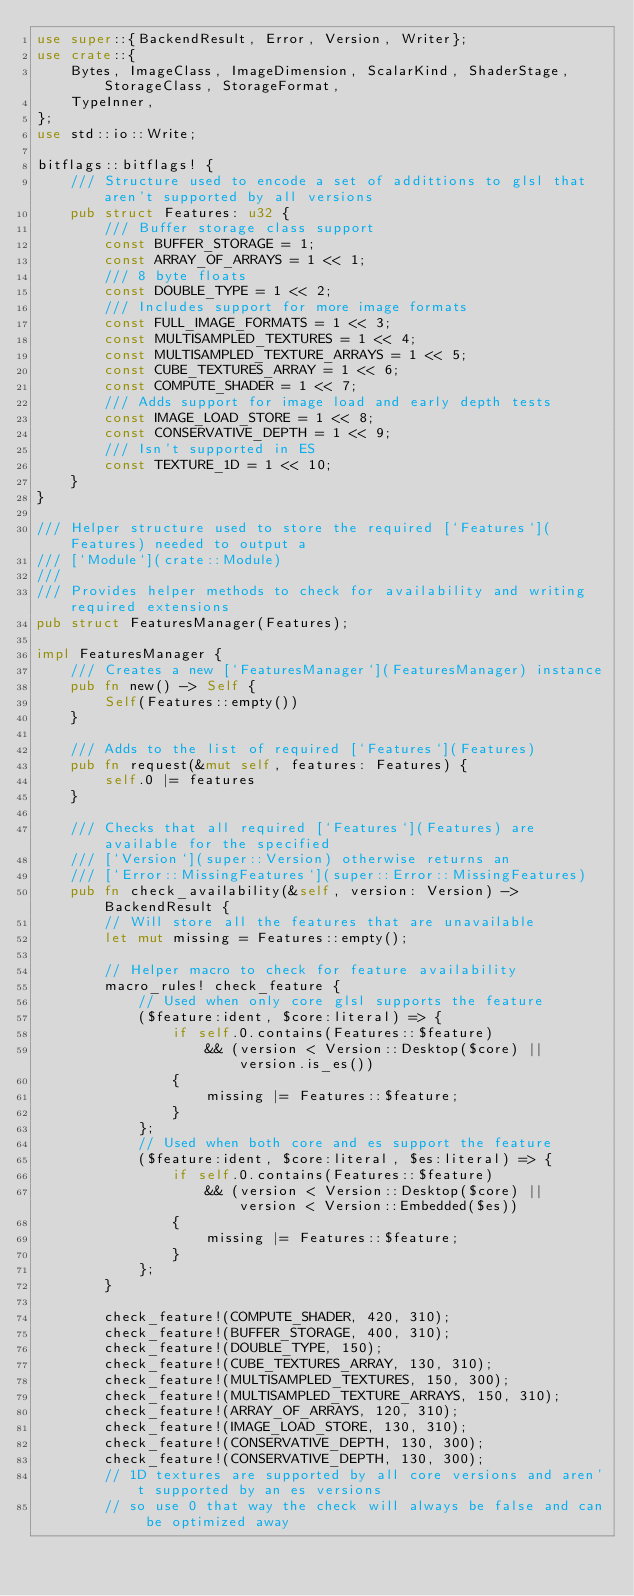<code> <loc_0><loc_0><loc_500><loc_500><_Rust_>use super::{BackendResult, Error, Version, Writer};
use crate::{
    Bytes, ImageClass, ImageDimension, ScalarKind, ShaderStage, StorageClass, StorageFormat,
    TypeInner,
};
use std::io::Write;

bitflags::bitflags! {
    /// Structure used to encode a set of addittions to glsl that aren't supported by all versions
    pub struct Features: u32 {
        /// Buffer storage class support
        const BUFFER_STORAGE = 1;
        const ARRAY_OF_ARRAYS = 1 << 1;
        /// 8 byte floats
        const DOUBLE_TYPE = 1 << 2;
        /// Includes support for more image formats
        const FULL_IMAGE_FORMATS = 1 << 3;
        const MULTISAMPLED_TEXTURES = 1 << 4;
        const MULTISAMPLED_TEXTURE_ARRAYS = 1 << 5;
        const CUBE_TEXTURES_ARRAY = 1 << 6;
        const COMPUTE_SHADER = 1 << 7;
        /// Adds support for image load and early depth tests
        const IMAGE_LOAD_STORE = 1 << 8;
        const CONSERVATIVE_DEPTH = 1 << 9;
        /// Isn't supported in ES
        const TEXTURE_1D = 1 << 10;
    }
}

/// Helper structure used to store the required [`Features`](Features) needed to output a
/// [`Module`](crate::Module)
///
/// Provides helper methods to check for availability and writing required extensions
pub struct FeaturesManager(Features);

impl FeaturesManager {
    /// Creates a new [`FeaturesManager`](FeaturesManager) instance
    pub fn new() -> Self {
        Self(Features::empty())
    }

    /// Adds to the list of required [`Features`](Features)
    pub fn request(&mut self, features: Features) {
        self.0 |= features
    }

    /// Checks that all required [`Features`](Features) are available for the specified
    /// [`Version`](super::Version) otherwise returns an
    /// [`Error::MissingFeatures`](super::Error::MissingFeatures)
    pub fn check_availability(&self, version: Version) -> BackendResult {
        // Will store all the features that are unavailable
        let mut missing = Features::empty();

        // Helper macro to check for feature availability
        macro_rules! check_feature {
            // Used when only core glsl supports the feature
            ($feature:ident, $core:literal) => {
                if self.0.contains(Features::$feature)
                    && (version < Version::Desktop($core) || version.is_es())
                {
                    missing |= Features::$feature;
                }
            };
            // Used when both core and es support the feature
            ($feature:ident, $core:literal, $es:literal) => {
                if self.0.contains(Features::$feature)
                    && (version < Version::Desktop($core) || version < Version::Embedded($es))
                {
                    missing |= Features::$feature;
                }
            };
        }

        check_feature!(COMPUTE_SHADER, 420, 310);
        check_feature!(BUFFER_STORAGE, 400, 310);
        check_feature!(DOUBLE_TYPE, 150);
        check_feature!(CUBE_TEXTURES_ARRAY, 130, 310);
        check_feature!(MULTISAMPLED_TEXTURES, 150, 300);
        check_feature!(MULTISAMPLED_TEXTURE_ARRAYS, 150, 310);
        check_feature!(ARRAY_OF_ARRAYS, 120, 310);
        check_feature!(IMAGE_LOAD_STORE, 130, 310);
        check_feature!(CONSERVATIVE_DEPTH, 130, 300);
        check_feature!(CONSERVATIVE_DEPTH, 130, 300);
        // 1D textures are supported by all core versions and aren't supported by an es versions
        // so use 0 that way the check will always be false and can be optimized away</code> 